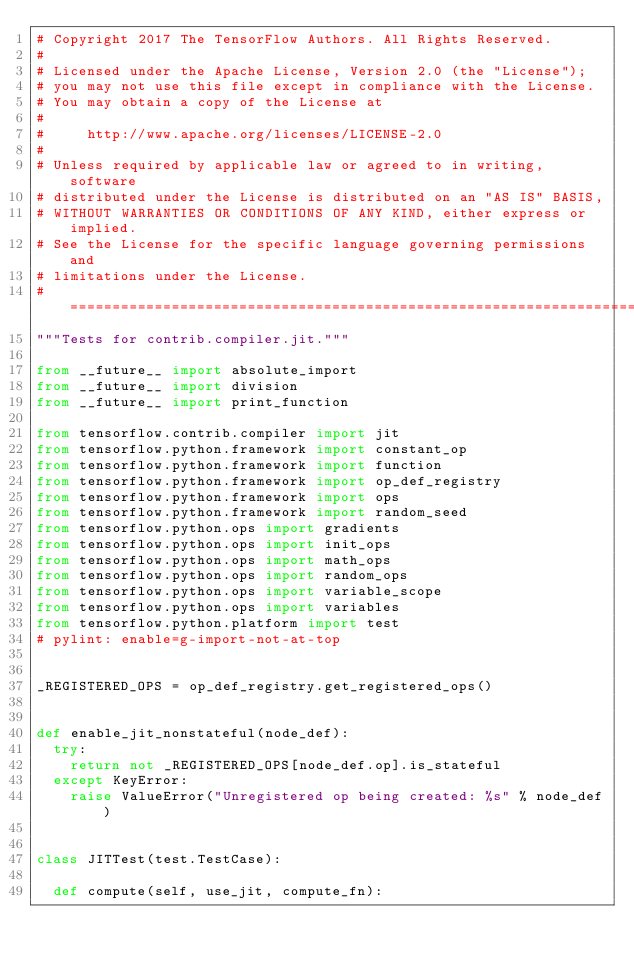Convert code to text. <code><loc_0><loc_0><loc_500><loc_500><_Python_># Copyright 2017 The TensorFlow Authors. All Rights Reserved.
#
# Licensed under the Apache License, Version 2.0 (the "License");
# you may not use this file except in compliance with the License.
# You may obtain a copy of the License at
#
#     http://www.apache.org/licenses/LICENSE-2.0
#
# Unless required by applicable law or agreed to in writing, software
# distributed under the License is distributed on an "AS IS" BASIS,
# WITHOUT WARRANTIES OR CONDITIONS OF ANY KIND, either express or implied.
# See the License for the specific language governing permissions and
# limitations under the License.
# ==============================================================================
"""Tests for contrib.compiler.jit."""

from __future__ import absolute_import
from __future__ import division
from __future__ import print_function

from tensorflow.contrib.compiler import jit
from tensorflow.python.framework import constant_op
from tensorflow.python.framework import function
from tensorflow.python.framework import op_def_registry
from tensorflow.python.framework import ops
from tensorflow.python.framework import random_seed
from tensorflow.python.ops import gradients
from tensorflow.python.ops import init_ops
from tensorflow.python.ops import math_ops
from tensorflow.python.ops import random_ops
from tensorflow.python.ops import variable_scope
from tensorflow.python.ops import variables
from tensorflow.python.platform import test
# pylint: enable=g-import-not-at-top


_REGISTERED_OPS = op_def_registry.get_registered_ops()


def enable_jit_nonstateful(node_def):
  try:
    return not _REGISTERED_OPS[node_def.op].is_stateful
  except KeyError:
    raise ValueError("Unregistered op being created: %s" % node_def)


class JITTest(test.TestCase):

  def compute(self, use_jit, compute_fn):</code> 